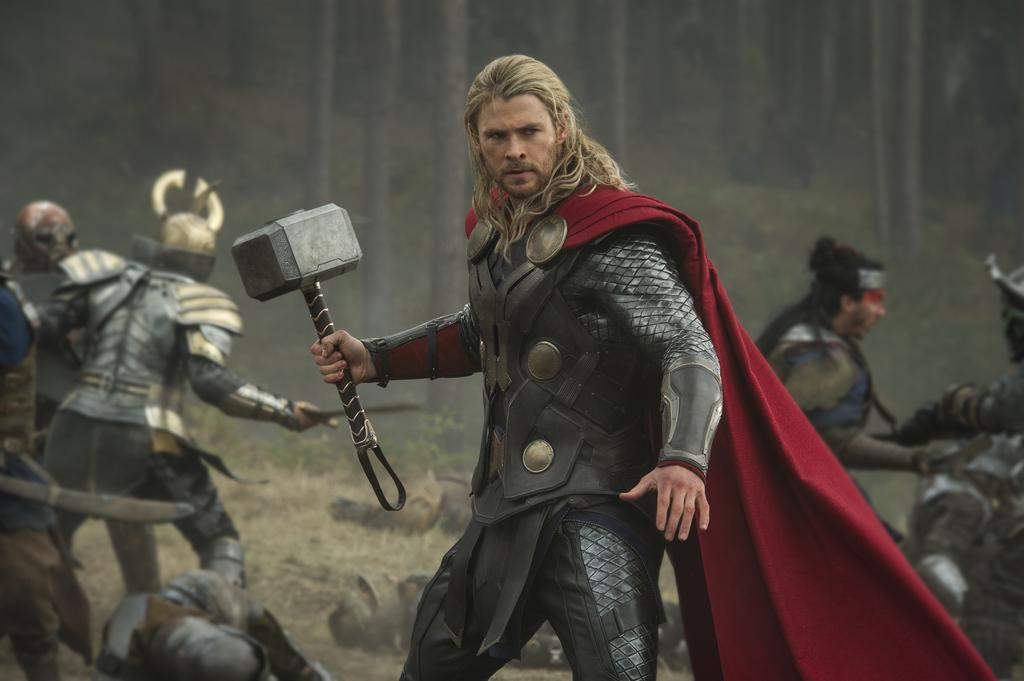What are the people in the image wearing? The people in the image are wearing safety jackets. What are the people holding in the image? The people are holding objects. Can you describe the man's headgear in the image? The man is wearing a helmet in the image. What can be seen in the background of the image? There are trees in the background of the image. What shape is the temper of the trees in the image? There is no mention of the temper of the trees in the image, and trees do not have a temper. Additionally, trees are not shaped like a temper. 